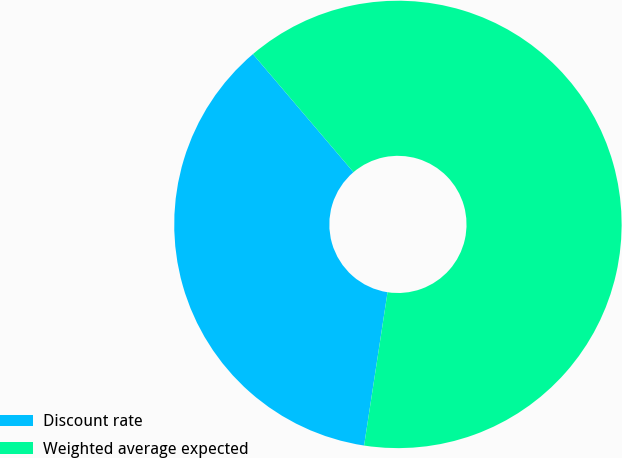<chart> <loc_0><loc_0><loc_500><loc_500><pie_chart><fcel>Discount rate<fcel>Weighted average expected<nl><fcel>36.36%<fcel>63.64%<nl></chart> 